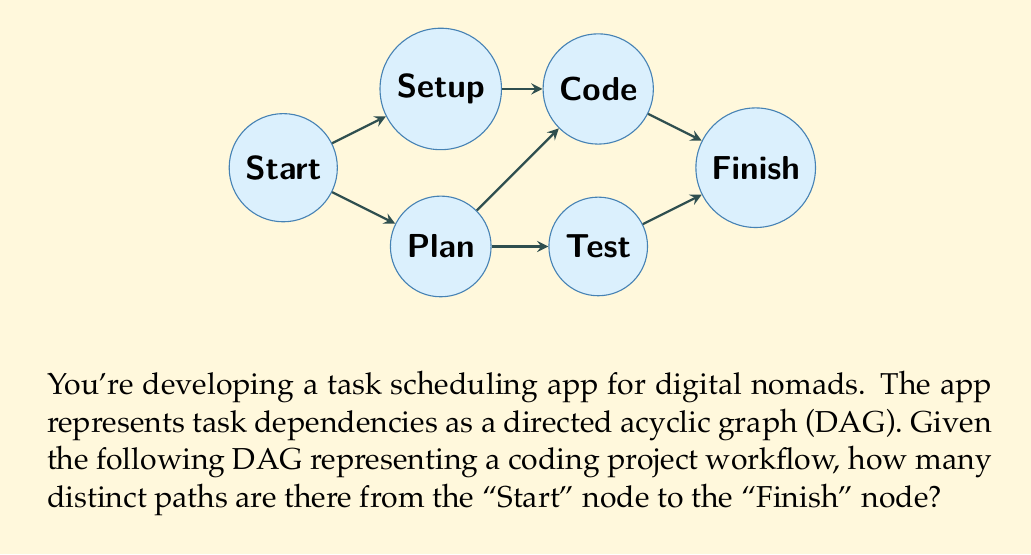Show me your answer to this math problem. To solve this problem, we'll use a dynamic programming approach, which is particularly useful for DAGs. We'll count the number of paths to each node, starting from the "Start" node and moving towards the "Finish" node.

Let's label our nodes:
A: Start
B: Setup
C: Plan
D: Code
E: Test
F: Finish

We'll create an array to store the number of paths to each node:

1. Initialize:
   paths[A] = 1 (there's one way to start)
   paths[B] = paths[C] = paths[D] = paths[E] = paths[F] = 0

2. Process nodes in topological order (A, B, C, D, E, F):

   For node A:
   - Already initialized

   For node B:
   paths[B] = paths[A] = 1

   For node C:
   paths[C] = paths[A] = 1

   For node D:
   paths[D] = paths[B] + paths[C] = 1 + 1 = 2

   For node E:
   paths[E] = paths[C] = 1

   For node F:
   paths[F] = paths[D] + paths[E] = 2 + 1 = 3

The number of distinct paths from Start to Finish is given by paths[F], which is 3.

We can verify this by listing all possible paths:
1. Start -> Setup -> Code -> Finish
2. Start -> Plan -> Code -> Finish
3. Start -> Plan -> Test -> Finish

This dynamic programming approach has a time complexity of $O(V + E)$, where $V$ is the number of vertices and $E$ is the number of edges in the graph, making it efficient for large DAGs.
Answer: 3 